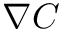<formula> <loc_0><loc_0><loc_500><loc_500>\nabla C</formula> 